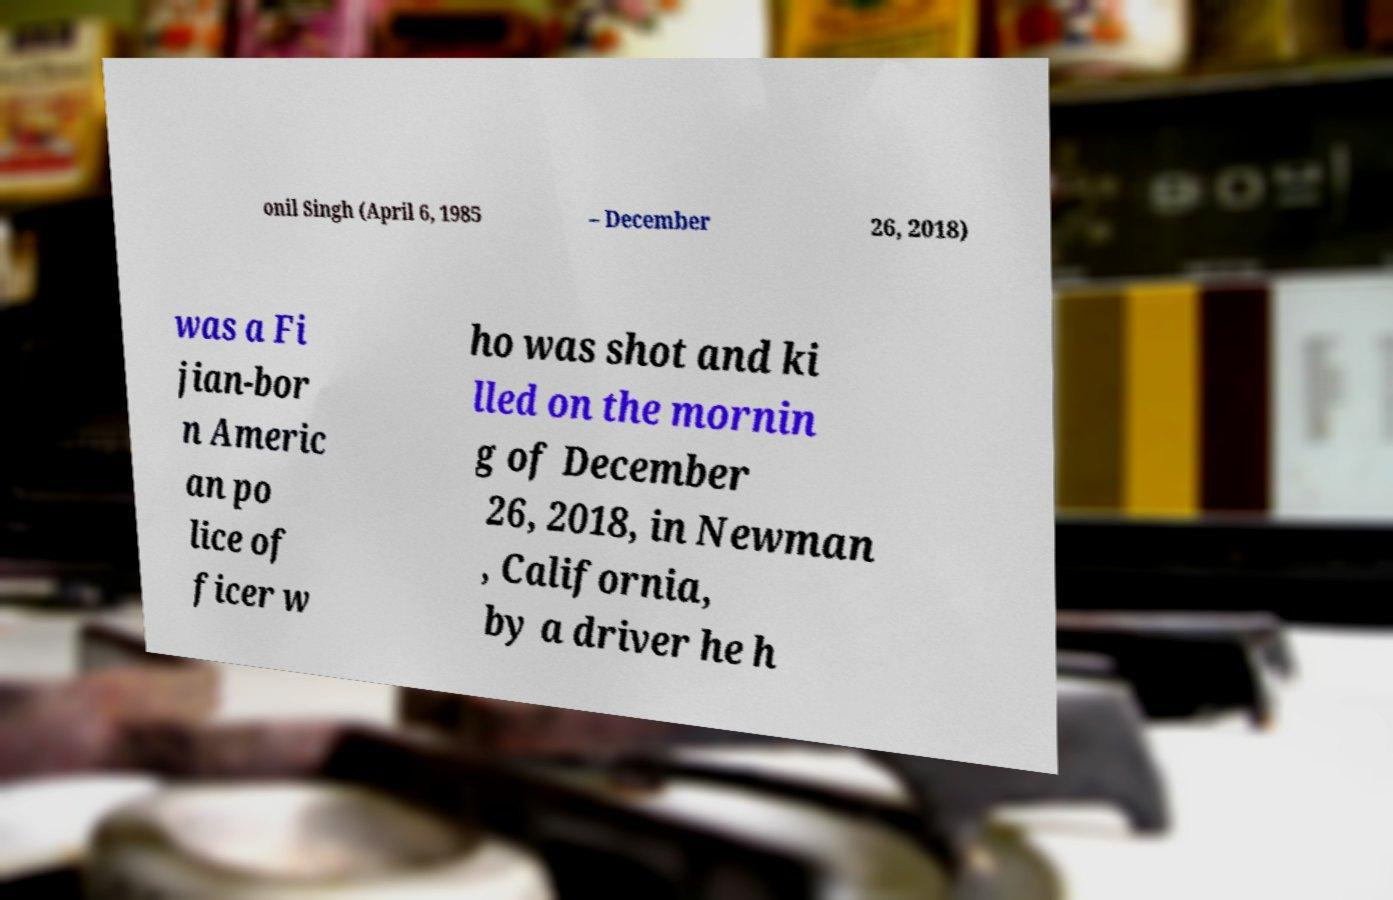Could you extract and type out the text from this image? onil Singh (April 6, 1985 – December 26, 2018) was a Fi jian-bor n Americ an po lice of ficer w ho was shot and ki lled on the mornin g of December 26, 2018, in Newman , California, by a driver he h 